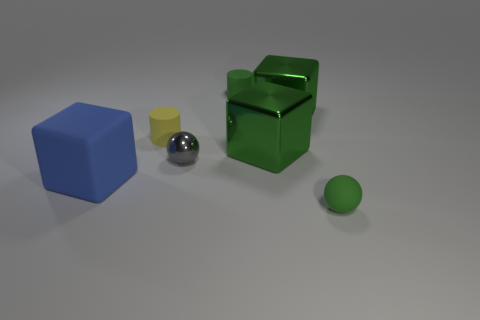How many other objects are the same shape as the tiny yellow matte object?
Keep it short and to the point. 1. What is the shape of the rubber thing that is both left of the green matte cylinder and behind the big matte block?
Your answer should be compact. Cylinder. What size is the cylinder that is in front of the green cylinder?
Provide a short and direct response. Small. Does the yellow object have the same size as the green cylinder?
Your response must be concise. Yes. Is the number of small green things on the left side of the matte sphere less than the number of big green metal cubes in front of the rubber cube?
Make the answer very short. No. There is a matte thing that is to the left of the gray sphere and in front of the tiny shiny ball; what size is it?
Make the answer very short. Large. Are there any blue matte things that are to the left of the small green object behind the small green matte ball in front of the blue matte block?
Provide a succinct answer. Yes. Are there any small blue things?
Ensure brevity in your answer.  No. Is the number of small matte cylinders that are in front of the small yellow thing greater than the number of green things behind the small gray ball?
Keep it short and to the point. No. There is a cube that is the same material as the tiny green sphere; what is its size?
Give a very brief answer. Large. 